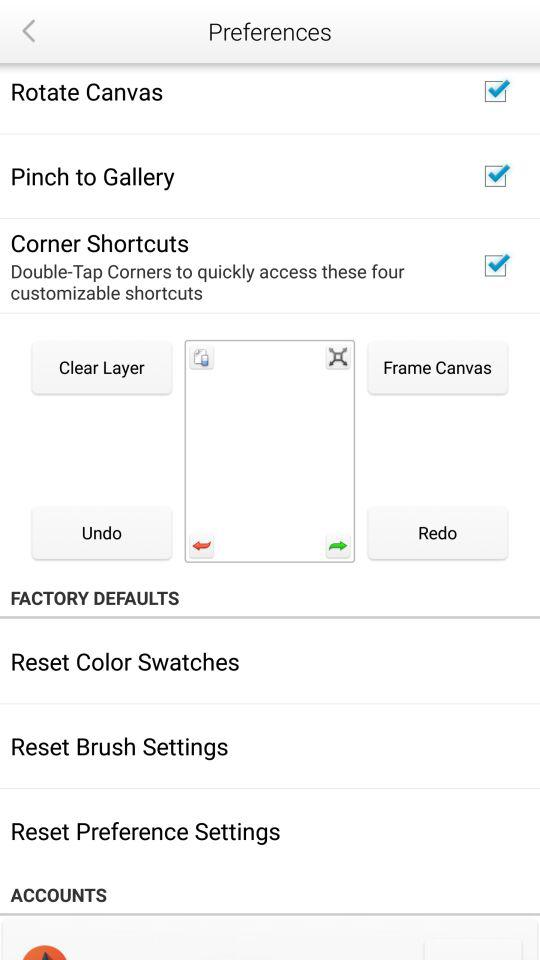What is the status of "Corner Shortcuts"? The status is "on". 